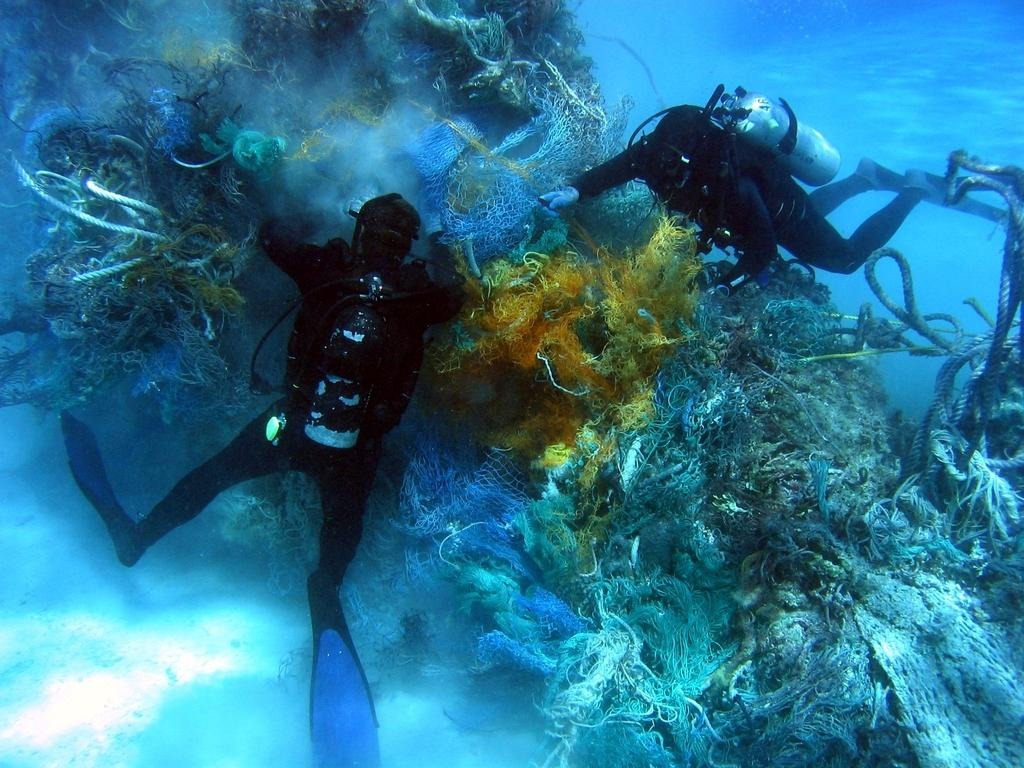How many people are in the water in the image? There are two persons in the water in the image. What objects can be seen in the image besides the people? There are cylinders and ropes in the image. What type of picture is hanging on the wall in the image? There is no wall or picture present in the image; it features two persons in the water with cylinders and ropes. Can you see any bees or needles in the image? No, there are no bees or needles present in the image. 